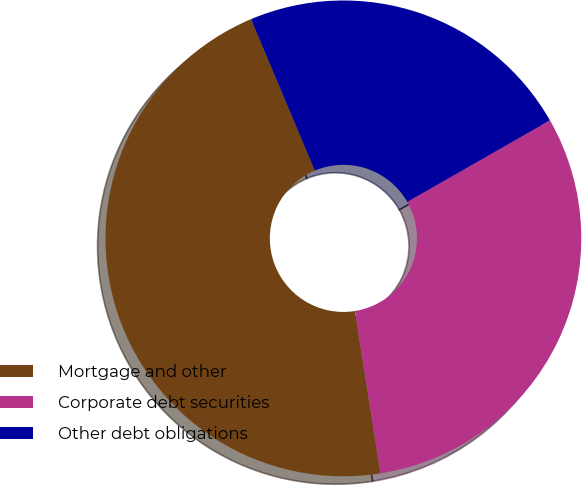Convert chart to OTSL. <chart><loc_0><loc_0><loc_500><loc_500><pie_chart><fcel>Mortgage and other<fcel>Corporate debt securities<fcel>Other debt obligations<nl><fcel>46.15%<fcel>30.77%<fcel>23.08%<nl></chart> 